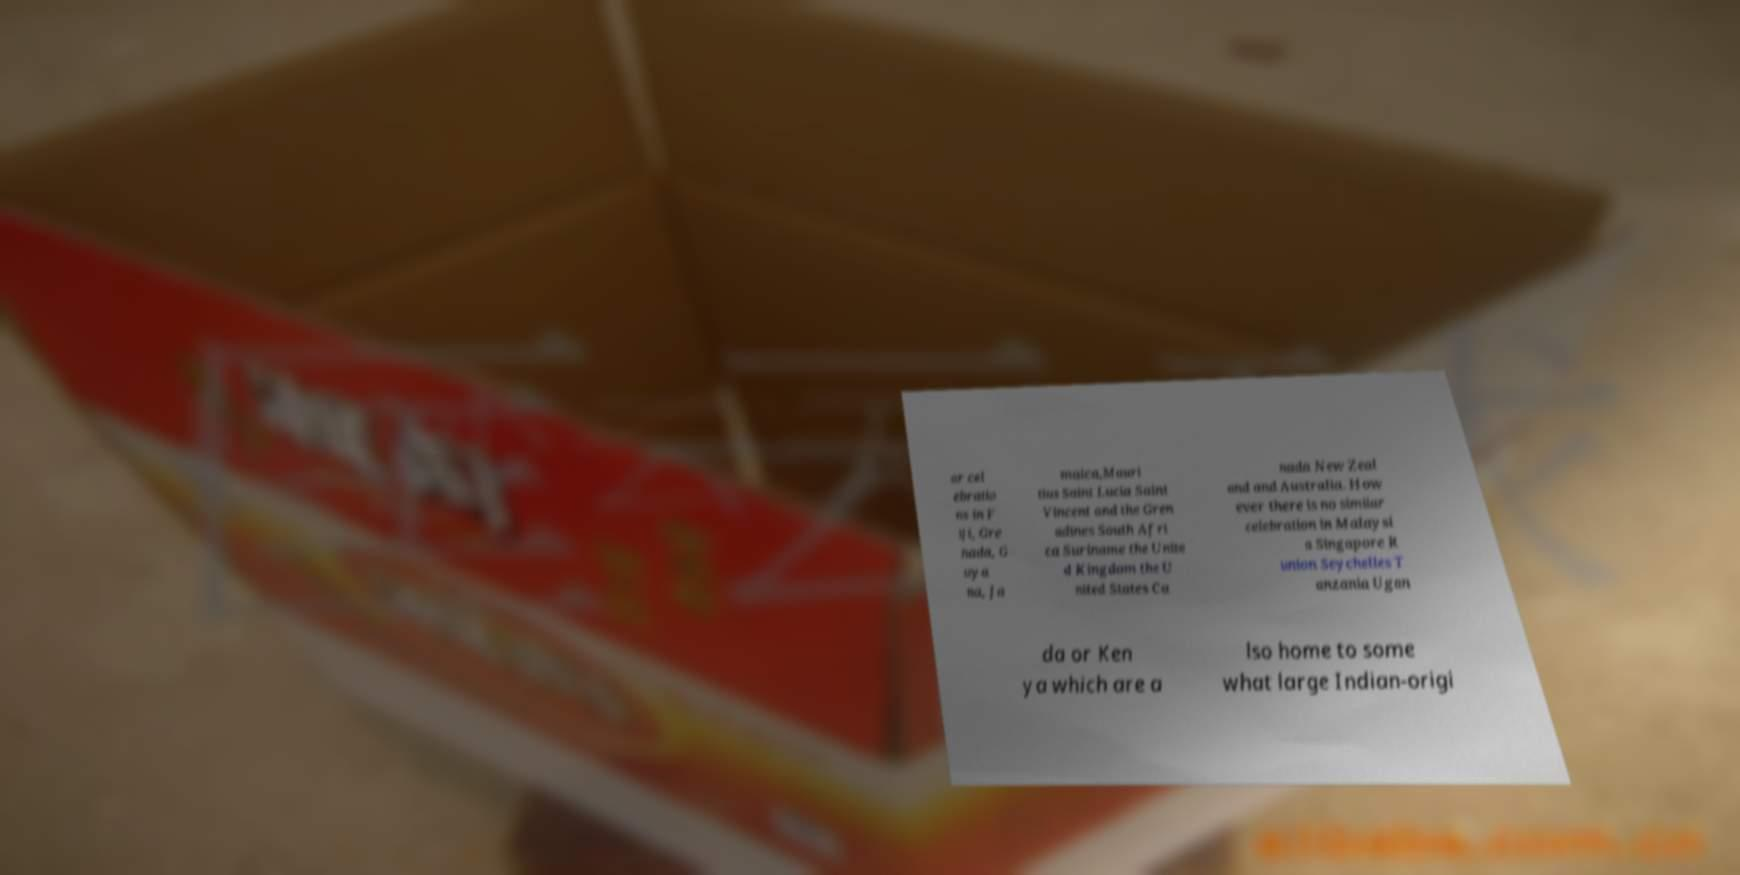Please identify and transcribe the text found in this image. ar cel ebratio ns in F iji, Gre nada, G uya na, Ja maica,Mauri tius Saint Lucia Saint Vincent and the Gren adines South Afri ca Suriname the Unite d Kingdom the U nited States Ca nada New Zeal and and Australia. How ever there is no similar celebration in Malaysi a Singapore R union Seychelles T anzania Ugan da or Ken ya which are a lso home to some what large Indian-origi 